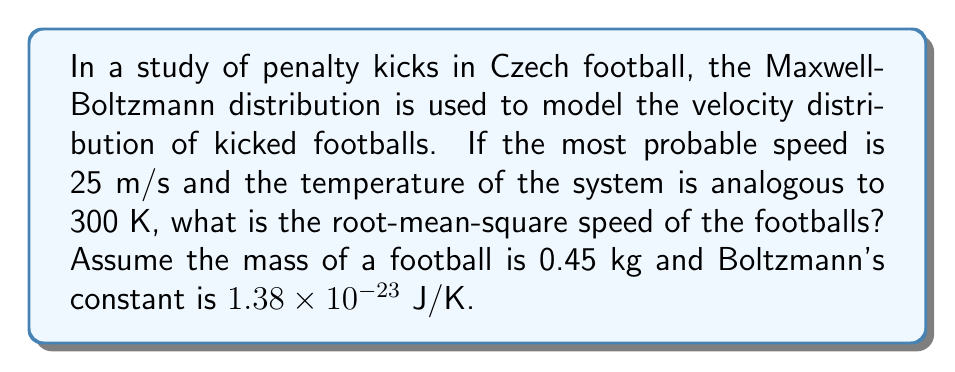What is the answer to this math problem? Let's approach this step-by-step:

1) The Maxwell-Boltzmann distribution gives the most probable speed $v_p$ as:

   $$v_p = \sqrt{\frac{2kT}{m}}$$

   where $k$ is Boltzmann's constant, $T$ is temperature, and $m$ is mass.

2) We're given $v_p = 25$ m/s, $T = 300$ K, $m = 0.45$ kg, and $k = 1.38 \times 10^{-23}$ J/K.

3) The root-mean-square speed $v_{rms}$ is related to the most probable speed by:

   $$v_{rms} = \sqrt{\frac{3}{2}}v_p$$

4) Substituting the given $v_p$:

   $$v_{rms} = \sqrt{\frac{3}{2}} \cdot 25$$

5) Calculate:

   $$v_{rms} = \sqrt{1.5} \cdot 25 \approx 30.62 \text{ m/s}$$
Answer: $30.62 \text{ m/s}$ 